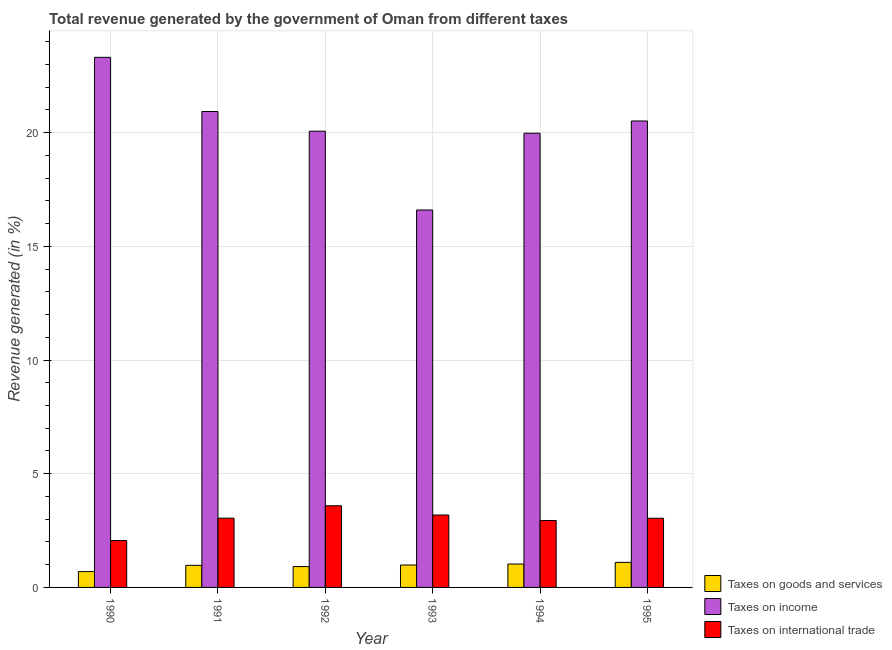Are the number of bars per tick equal to the number of legend labels?
Ensure brevity in your answer.  Yes. How many bars are there on the 6th tick from the left?
Your response must be concise. 3. What is the percentage of revenue generated by taxes on goods and services in 1995?
Your answer should be very brief. 1.1. Across all years, what is the maximum percentage of revenue generated by tax on international trade?
Your answer should be compact. 3.59. Across all years, what is the minimum percentage of revenue generated by tax on international trade?
Your answer should be compact. 2.06. What is the total percentage of revenue generated by tax on international trade in the graph?
Your answer should be very brief. 17.87. What is the difference between the percentage of revenue generated by tax on international trade in 1993 and that in 1995?
Provide a succinct answer. 0.14. What is the difference between the percentage of revenue generated by tax on international trade in 1995 and the percentage of revenue generated by taxes on goods and services in 1990?
Provide a succinct answer. 0.98. What is the average percentage of revenue generated by taxes on income per year?
Provide a short and direct response. 20.23. In the year 1990, what is the difference between the percentage of revenue generated by tax on international trade and percentage of revenue generated by taxes on goods and services?
Give a very brief answer. 0. What is the ratio of the percentage of revenue generated by taxes on goods and services in 1991 to that in 1995?
Your response must be concise. 0.88. Is the percentage of revenue generated by taxes on income in 1990 less than that in 1995?
Offer a terse response. No. Is the difference between the percentage of revenue generated by taxes on income in 1991 and 1993 greater than the difference between the percentage of revenue generated by taxes on goods and services in 1991 and 1993?
Give a very brief answer. No. What is the difference between the highest and the second highest percentage of revenue generated by tax on international trade?
Ensure brevity in your answer.  0.41. What is the difference between the highest and the lowest percentage of revenue generated by taxes on goods and services?
Your answer should be very brief. 0.41. In how many years, is the percentage of revenue generated by taxes on income greater than the average percentage of revenue generated by taxes on income taken over all years?
Offer a terse response. 3. Is the sum of the percentage of revenue generated by taxes on goods and services in 1990 and 1991 greater than the maximum percentage of revenue generated by tax on international trade across all years?
Your answer should be very brief. Yes. What does the 1st bar from the left in 1991 represents?
Give a very brief answer. Taxes on goods and services. What does the 1st bar from the right in 1995 represents?
Provide a short and direct response. Taxes on international trade. How many years are there in the graph?
Give a very brief answer. 6. What is the difference between two consecutive major ticks on the Y-axis?
Give a very brief answer. 5. Does the graph contain grids?
Make the answer very short. Yes. How are the legend labels stacked?
Offer a very short reply. Vertical. What is the title of the graph?
Offer a terse response. Total revenue generated by the government of Oman from different taxes. Does "Central government" appear as one of the legend labels in the graph?
Provide a succinct answer. No. What is the label or title of the X-axis?
Your answer should be very brief. Year. What is the label or title of the Y-axis?
Ensure brevity in your answer.  Revenue generated (in %). What is the Revenue generated (in %) of Taxes on goods and services in 1990?
Your response must be concise. 0.7. What is the Revenue generated (in %) of Taxes on income in 1990?
Provide a succinct answer. 23.31. What is the Revenue generated (in %) in Taxes on international trade in 1990?
Your response must be concise. 2.06. What is the Revenue generated (in %) of Taxes on goods and services in 1991?
Give a very brief answer. 0.97. What is the Revenue generated (in %) in Taxes on income in 1991?
Your response must be concise. 20.93. What is the Revenue generated (in %) in Taxes on international trade in 1991?
Provide a short and direct response. 3.05. What is the Revenue generated (in %) of Taxes on goods and services in 1992?
Offer a very short reply. 0.92. What is the Revenue generated (in %) of Taxes on income in 1992?
Your response must be concise. 20.06. What is the Revenue generated (in %) of Taxes on international trade in 1992?
Ensure brevity in your answer.  3.59. What is the Revenue generated (in %) of Taxes on goods and services in 1993?
Provide a succinct answer. 0.99. What is the Revenue generated (in %) of Taxes on income in 1993?
Provide a succinct answer. 16.6. What is the Revenue generated (in %) in Taxes on international trade in 1993?
Give a very brief answer. 3.18. What is the Revenue generated (in %) of Taxes on goods and services in 1994?
Your response must be concise. 1.03. What is the Revenue generated (in %) of Taxes on income in 1994?
Provide a short and direct response. 19.97. What is the Revenue generated (in %) in Taxes on international trade in 1994?
Provide a succinct answer. 2.94. What is the Revenue generated (in %) in Taxes on goods and services in 1995?
Offer a terse response. 1.1. What is the Revenue generated (in %) in Taxes on income in 1995?
Your response must be concise. 20.51. What is the Revenue generated (in %) in Taxes on international trade in 1995?
Provide a succinct answer. 3.04. Across all years, what is the maximum Revenue generated (in %) in Taxes on goods and services?
Your answer should be very brief. 1.1. Across all years, what is the maximum Revenue generated (in %) in Taxes on income?
Offer a terse response. 23.31. Across all years, what is the maximum Revenue generated (in %) in Taxes on international trade?
Give a very brief answer. 3.59. Across all years, what is the minimum Revenue generated (in %) in Taxes on goods and services?
Make the answer very short. 0.7. Across all years, what is the minimum Revenue generated (in %) in Taxes on income?
Your answer should be compact. 16.6. Across all years, what is the minimum Revenue generated (in %) of Taxes on international trade?
Your answer should be compact. 2.06. What is the total Revenue generated (in %) of Taxes on goods and services in the graph?
Your answer should be compact. 5.7. What is the total Revenue generated (in %) in Taxes on income in the graph?
Keep it short and to the point. 121.38. What is the total Revenue generated (in %) in Taxes on international trade in the graph?
Ensure brevity in your answer.  17.87. What is the difference between the Revenue generated (in %) of Taxes on goods and services in 1990 and that in 1991?
Provide a short and direct response. -0.27. What is the difference between the Revenue generated (in %) of Taxes on income in 1990 and that in 1991?
Your answer should be very brief. 2.38. What is the difference between the Revenue generated (in %) in Taxes on international trade in 1990 and that in 1991?
Provide a short and direct response. -0.98. What is the difference between the Revenue generated (in %) in Taxes on goods and services in 1990 and that in 1992?
Provide a succinct answer. -0.22. What is the difference between the Revenue generated (in %) in Taxes on income in 1990 and that in 1992?
Provide a succinct answer. 3.25. What is the difference between the Revenue generated (in %) of Taxes on international trade in 1990 and that in 1992?
Provide a succinct answer. -1.53. What is the difference between the Revenue generated (in %) in Taxes on goods and services in 1990 and that in 1993?
Give a very brief answer. -0.29. What is the difference between the Revenue generated (in %) in Taxes on income in 1990 and that in 1993?
Ensure brevity in your answer.  6.71. What is the difference between the Revenue generated (in %) in Taxes on international trade in 1990 and that in 1993?
Give a very brief answer. -1.12. What is the difference between the Revenue generated (in %) of Taxes on goods and services in 1990 and that in 1994?
Ensure brevity in your answer.  -0.33. What is the difference between the Revenue generated (in %) in Taxes on income in 1990 and that in 1994?
Provide a succinct answer. 3.34. What is the difference between the Revenue generated (in %) in Taxes on international trade in 1990 and that in 1994?
Your response must be concise. -0.88. What is the difference between the Revenue generated (in %) of Taxes on goods and services in 1990 and that in 1995?
Your response must be concise. -0.41. What is the difference between the Revenue generated (in %) in Taxes on income in 1990 and that in 1995?
Offer a very short reply. 2.8. What is the difference between the Revenue generated (in %) of Taxes on international trade in 1990 and that in 1995?
Your answer should be compact. -0.98. What is the difference between the Revenue generated (in %) in Taxes on goods and services in 1991 and that in 1992?
Your answer should be compact. 0.05. What is the difference between the Revenue generated (in %) in Taxes on income in 1991 and that in 1992?
Ensure brevity in your answer.  0.87. What is the difference between the Revenue generated (in %) of Taxes on international trade in 1991 and that in 1992?
Offer a very short reply. -0.54. What is the difference between the Revenue generated (in %) in Taxes on goods and services in 1991 and that in 1993?
Make the answer very short. -0.01. What is the difference between the Revenue generated (in %) in Taxes on income in 1991 and that in 1993?
Your answer should be very brief. 4.33. What is the difference between the Revenue generated (in %) of Taxes on international trade in 1991 and that in 1993?
Ensure brevity in your answer.  -0.14. What is the difference between the Revenue generated (in %) in Taxes on goods and services in 1991 and that in 1994?
Your response must be concise. -0.06. What is the difference between the Revenue generated (in %) in Taxes on income in 1991 and that in 1994?
Give a very brief answer. 0.96. What is the difference between the Revenue generated (in %) in Taxes on international trade in 1991 and that in 1994?
Your answer should be compact. 0.1. What is the difference between the Revenue generated (in %) of Taxes on goods and services in 1991 and that in 1995?
Your answer should be compact. -0.13. What is the difference between the Revenue generated (in %) of Taxes on income in 1991 and that in 1995?
Keep it short and to the point. 0.42. What is the difference between the Revenue generated (in %) of Taxes on international trade in 1991 and that in 1995?
Keep it short and to the point. 0. What is the difference between the Revenue generated (in %) in Taxes on goods and services in 1992 and that in 1993?
Your answer should be very brief. -0.07. What is the difference between the Revenue generated (in %) of Taxes on income in 1992 and that in 1993?
Your answer should be very brief. 3.47. What is the difference between the Revenue generated (in %) in Taxes on international trade in 1992 and that in 1993?
Ensure brevity in your answer.  0.41. What is the difference between the Revenue generated (in %) in Taxes on goods and services in 1992 and that in 1994?
Your answer should be very brief. -0.11. What is the difference between the Revenue generated (in %) of Taxes on income in 1992 and that in 1994?
Give a very brief answer. 0.09. What is the difference between the Revenue generated (in %) in Taxes on international trade in 1992 and that in 1994?
Provide a short and direct response. 0.65. What is the difference between the Revenue generated (in %) of Taxes on goods and services in 1992 and that in 1995?
Offer a very short reply. -0.18. What is the difference between the Revenue generated (in %) in Taxes on income in 1992 and that in 1995?
Your answer should be very brief. -0.45. What is the difference between the Revenue generated (in %) in Taxes on international trade in 1992 and that in 1995?
Your answer should be compact. 0.55. What is the difference between the Revenue generated (in %) in Taxes on goods and services in 1993 and that in 1994?
Provide a short and direct response. -0.04. What is the difference between the Revenue generated (in %) in Taxes on income in 1993 and that in 1994?
Your answer should be very brief. -3.38. What is the difference between the Revenue generated (in %) in Taxes on international trade in 1993 and that in 1994?
Make the answer very short. 0.24. What is the difference between the Revenue generated (in %) in Taxes on goods and services in 1993 and that in 1995?
Your answer should be very brief. -0.12. What is the difference between the Revenue generated (in %) in Taxes on income in 1993 and that in 1995?
Make the answer very short. -3.91. What is the difference between the Revenue generated (in %) of Taxes on international trade in 1993 and that in 1995?
Provide a succinct answer. 0.14. What is the difference between the Revenue generated (in %) of Taxes on goods and services in 1994 and that in 1995?
Your answer should be very brief. -0.07. What is the difference between the Revenue generated (in %) in Taxes on income in 1994 and that in 1995?
Provide a short and direct response. -0.54. What is the difference between the Revenue generated (in %) in Taxes on international trade in 1994 and that in 1995?
Your answer should be compact. -0.1. What is the difference between the Revenue generated (in %) of Taxes on goods and services in 1990 and the Revenue generated (in %) of Taxes on income in 1991?
Ensure brevity in your answer.  -20.23. What is the difference between the Revenue generated (in %) of Taxes on goods and services in 1990 and the Revenue generated (in %) of Taxes on international trade in 1991?
Your response must be concise. -2.35. What is the difference between the Revenue generated (in %) of Taxes on income in 1990 and the Revenue generated (in %) of Taxes on international trade in 1991?
Ensure brevity in your answer.  20.26. What is the difference between the Revenue generated (in %) in Taxes on goods and services in 1990 and the Revenue generated (in %) in Taxes on income in 1992?
Your answer should be very brief. -19.37. What is the difference between the Revenue generated (in %) in Taxes on goods and services in 1990 and the Revenue generated (in %) in Taxes on international trade in 1992?
Make the answer very short. -2.89. What is the difference between the Revenue generated (in %) in Taxes on income in 1990 and the Revenue generated (in %) in Taxes on international trade in 1992?
Your response must be concise. 19.72. What is the difference between the Revenue generated (in %) of Taxes on goods and services in 1990 and the Revenue generated (in %) of Taxes on income in 1993?
Ensure brevity in your answer.  -15.9. What is the difference between the Revenue generated (in %) of Taxes on goods and services in 1990 and the Revenue generated (in %) of Taxes on international trade in 1993?
Offer a terse response. -2.49. What is the difference between the Revenue generated (in %) of Taxes on income in 1990 and the Revenue generated (in %) of Taxes on international trade in 1993?
Give a very brief answer. 20.13. What is the difference between the Revenue generated (in %) in Taxes on goods and services in 1990 and the Revenue generated (in %) in Taxes on income in 1994?
Offer a terse response. -19.28. What is the difference between the Revenue generated (in %) of Taxes on goods and services in 1990 and the Revenue generated (in %) of Taxes on international trade in 1994?
Give a very brief answer. -2.25. What is the difference between the Revenue generated (in %) in Taxes on income in 1990 and the Revenue generated (in %) in Taxes on international trade in 1994?
Your answer should be very brief. 20.37. What is the difference between the Revenue generated (in %) of Taxes on goods and services in 1990 and the Revenue generated (in %) of Taxes on income in 1995?
Provide a succinct answer. -19.82. What is the difference between the Revenue generated (in %) of Taxes on goods and services in 1990 and the Revenue generated (in %) of Taxes on international trade in 1995?
Your answer should be compact. -2.35. What is the difference between the Revenue generated (in %) in Taxes on income in 1990 and the Revenue generated (in %) in Taxes on international trade in 1995?
Provide a succinct answer. 20.27. What is the difference between the Revenue generated (in %) of Taxes on goods and services in 1991 and the Revenue generated (in %) of Taxes on income in 1992?
Provide a succinct answer. -19.09. What is the difference between the Revenue generated (in %) in Taxes on goods and services in 1991 and the Revenue generated (in %) in Taxes on international trade in 1992?
Provide a succinct answer. -2.62. What is the difference between the Revenue generated (in %) of Taxes on income in 1991 and the Revenue generated (in %) of Taxes on international trade in 1992?
Your response must be concise. 17.34. What is the difference between the Revenue generated (in %) in Taxes on goods and services in 1991 and the Revenue generated (in %) in Taxes on income in 1993?
Provide a succinct answer. -15.63. What is the difference between the Revenue generated (in %) of Taxes on goods and services in 1991 and the Revenue generated (in %) of Taxes on international trade in 1993?
Offer a terse response. -2.21. What is the difference between the Revenue generated (in %) in Taxes on income in 1991 and the Revenue generated (in %) in Taxes on international trade in 1993?
Your response must be concise. 17.75. What is the difference between the Revenue generated (in %) in Taxes on goods and services in 1991 and the Revenue generated (in %) in Taxes on income in 1994?
Provide a short and direct response. -19. What is the difference between the Revenue generated (in %) in Taxes on goods and services in 1991 and the Revenue generated (in %) in Taxes on international trade in 1994?
Provide a short and direct response. -1.97. What is the difference between the Revenue generated (in %) of Taxes on income in 1991 and the Revenue generated (in %) of Taxes on international trade in 1994?
Your response must be concise. 17.99. What is the difference between the Revenue generated (in %) of Taxes on goods and services in 1991 and the Revenue generated (in %) of Taxes on income in 1995?
Provide a short and direct response. -19.54. What is the difference between the Revenue generated (in %) in Taxes on goods and services in 1991 and the Revenue generated (in %) in Taxes on international trade in 1995?
Offer a very short reply. -2.07. What is the difference between the Revenue generated (in %) in Taxes on income in 1991 and the Revenue generated (in %) in Taxes on international trade in 1995?
Provide a succinct answer. 17.89. What is the difference between the Revenue generated (in %) in Taxes on goods and services in 1992 and the Revenue generated (in %) in Taxes on income in 1993?
Your response must be concise. -15.68. What is the difference between the Revenue generated (in %) in Taxes on goods and services in 1992 and the Revenue generated (in %) in Taxes on international trade in 1993?
Provide a succinct answer. -2.27. What is the difference between the Revenue generated (in %) in Taxes on income in 1992 and the Revenue generated (in %) in Taxes on international trade in 1993?
Give a very brief answer. 16.88. What is the difference between the Revenue generated (in %) of Taxes on goods and services in 1992 and the Revenue generated (in %) of Taxes on income in 1994?
Your response must be concise. -19.06. What is the difference between the Revenue generated (in %) of Taxes on goods and services in 1992 and the Revenue generated (in %) of Taxes on international trade in 1994?
Provide a succinct answer. -2.03. What is the difference between the Revenue generated (in %) of Taxes on income in 1992 and the Revenue generated (in %) of Taxes on international trade in 1994?
Your response must be concise. 17.12. What is the difference between the Revenue generated (in %) of Taxes on goods and services in 1992 and the Revenue generated (in %) of Taxes on income in 1995?
Offer a terse response. -19.6. What is the difference between the Revenue generated (in %) in Taxes on goods and services in 1992 and the Revenue generated (in %) in Taxes on international trade in 1995?
Your answer should be very brief. -2.13. What is the difference between the Revenue generated (in %) of Taxes on income in 1992 and the Revenue generated (in %) of Taxes on international trade in 1995?
Provide a short and direct response. 17.02. What is the difference between the Revenue generated (in %) in Taxes on goods and services in 1993 and the Revenue generated (in %) in Taxes on income in 1994?
Provide a short and direct response. -18.99. What is the difference between the Revenue generated (in %) of Taxes on goods and services in 1993 and the Revenue generated (in %) of Taxes on international trade in 1994?
Your answer should be very brief. -1.96. What is the difference between the Revenue generated (in %) in Taxes on income in 1993 and the Revenue generated (in %) in Taxes on international trade in 1994?
Offer a terse response. 13.65. What is the difference between the Revenue generated (in %) of Taxes on goods and services in 1993 and the Revenue generated (in %) of Taxes on income in 1995?
Provide a succinct answer. -19.53. What is the difference between the Revenue generated (in %) of Taxes on goods and services in 1993 and the Revenue generated (in %) of Taxes on international trade in 1995?
Your answer should be compact. -2.06. What is the difference between the Revenue generated (in %) of Taxes on income in 1993 and the Revenue generated (in %) of Taxes on international trade in 1995?
Your answer should be very brief. 13.56. What is the difference between the Revenue generated (in %) of Taxes on goods and services in 1994 and the Revenue generated (in %) of Taxes on income in 1995?
Your response must be concise. -19.48. What is the difference between the Revenue generated (in %) of Taxes on goods and services in 1994 and the Revenue generated (in %) of Taxes on international trade in 1995?
Ensure brevity in your answer.  -2.01. What is the difference between the Revenue generated (in %) of Taxes on income in 1994 and the Revenue generated (in %) of Taxes on international trade in 1995?
Ensure brevity in your answer.  16.93. What is the average Revenue generated (in %) in Taxes on goods and services per year?
Make the answer very short. 0.95. What is the average Revenue generated (in %) in Taxes on income per year?
Make the answer very short. 20.23. What is the average Revenue generated (in %) of Taxes on international trade per year?
Your answer should be very brief. 2.98. In the year 1990, what is the difference between the Revenue generated (in %) of Taxes on goods and services and Revenue generated (in %) of Taxes on income?
Ensure brevity in your answer.  -22.61. In the year 1990, what is the difference between the Revenue generated (in %) in Taxes on goods and services and Revenue generated (in %) in Taxes on international trade?
Provide a short and direct response. -1.37. In the year 1990, what is the difference between the Revenue generated (in %) of Taxes on income and Revenue generated (in %) of Taxes on international trade?
Ensure brevity in your answer.  21.25. In the year 1991, what is the difference between the Revenue generated (in %) in Taxes on goods and services and Revenue generated (in %) in Taxes on income?
Your answer should be compact. -19.96. In the year 1991, what is the difference between the Revenue generated (in %) in Taxes on goods and services and Revenue generated (in %) in Taxes on international trade?
Your response must be concise. -2.07. In the year 1991, what is the difference between the Revenue generated (in %) in Taxes on income and Revenue generated (in %) in Taxes on international trade?
Give a very brief answer. 17.88. In the year 1992, what is the difference between the Revenue generated (in %) of Taxes on goods and services and Revenue generated (in %) of Taxes on income?
Keep it short and to the point. -19.15. In the year 1992, what is the difference between the Revenue generated (in %) in Taxes on goods and services and Revenue generated (in %) in Taxes on international trade?
Make the answer very short. -2.67. In the year 1992, what is the difference between the Revenue generated (in %) in Taxes on income and Revenue generated (in %) in Taxes on international trade?
Offer a terse response. 16.47. In the year 1993, what is the difference between the Revenue generated (in %) of Taxes on goods and services and Revenue generated (in %) of Taxes on income?
Offer a terse response. -15.61. In the year 1993, what is the difference between the Revenue generated (in %) in Taxes on goods and services and Revenue generated (in %) in Taxes on international trade?
Your answer should be very brief. -2.2. In the year 1993, what is the difference between the Revenue generated (in %) in Taxes on income and Revenue generated (in %) in Taxes on international trade?
Ensure brevity in your answer.  13.41. In the year 1994, what is the difference between the Revenue generated (in %) in Taxes on goods and services and Revenue generated (in %) in Taxes on income?
Give a very brief answer. -18.94. In the year 1994, what is the difference between the Revenue generated (in %) in Taxes on goods and services and Revenue generated (in %) in Taxes on international trade?
Make the answer very short. -1.92. In the year 1994, what is the difference between the Revenue generated (in %) in Taxes on income and Revenue generated (in %) in Taxes on international trade?
Make the answer very short. 17.03. In the year 1995, what is the difference between the Revenue generated (in %) of Taxes on goods and services and Revenue generated (in %) of Taxes on income?
Provide a succinct answer. -19.41. In the year 1995, what is the difference between the Revenue generated (in %) in Taxes on goods and services and Revenue generated (in %) in Taxes on international trade?
Provide a succinct answer. -1.94. In the year 1995, what is the difference between the Revenue generated (in %) in Taxes on income and Revenue generated (in %) in Taxes on international trade?
Provide a succinct answer. 17.47. What is the ratio of the Revenue generated (in %) of Taxes on goods and services in 1990 to that in 1991?
Make the answer very short. 0.72. What is the ratio of the Revenue generated (in %) in Taxes on income in 1990 to that in 1991?
Your response must be concise. 1.11. What is the ratio of the Revenue generated (in %) of Taxes on international trade in 1990 to that in 1991?
Offer a very short reply. 0.68. What is the ratio of the Revenue generated (in %) of Taxes on goods and services in 1990 to that in 1992?
Ensure brevity in your answer.  0.76. What is the ratio of the Revenue generated (in %) in Taxes on income in 1990 to that in 1992?
Make the answer very short. 1.16. What is the ratio of the Revenue generated (in %) in Taxes on international trade in 1990 to that in 1992?
Offer a very short reply. 0.57. What is the ratio of the Revenue generated (in %) in Taxes on goods and services in 1990 to that in 1993?
Provide a succinct answer. 0.71. What is the ratio of the Revenue generated (in %) in Taxes on income in 1990 to that in 1993?
Offer a terse response. 1.4. What is the ratio of the Revenue generated (in %) of Taxes on international trade in 1990 to that in 1993?
Your answer should be very brief. 0.65. What is the ratio of the Revenue generated (in %) of Taxes on goods and services in 1990 to that in 1994?
Your response must be concise. 0.68. What is the ratio of the Revenue generated (in %) in Taxes on income in 1990 to that in 1994?
Your answer should be very brief. 1.17. What is the ratio of the Revenue generated (in %) in Taxes on international trade in 1990 to that in 1994?
Offer a very short reply. 0.7. What is the ratio of the Revenue generated (in %) of Taxes on goods and services in 1990 to that in 1995?
Provide a short and direct response. 0.63. What is the ratio of the Revenue generated (in %) of Taxes on income in 1990 to that in 1995?
Your answer should be very brief. 1.14. What is the ratio of the Revenue generated (in %) of Taxes on international trade in 1990 to that in 1995?
Keep it short and to the point. 0.68. What is the ratio of the Revenue generated (in %) of Taxes on goods and services in 1991 to that in 1992?
Your answer should be very brief. 1.06. What is the ratio of the Revenue generated (in %) of Taxes on income in 1991 to that in 1992?
Offer a terse response. 1.04. What is the ratio of the Revenue generated (in %) of Taxes on international trade in 1991 to that in 1992?
Offer a very short reply. 0.85. What is the ratio of the Revenue generated (in %) in Taxes on goods and services in 1991 to that in 1993?
Give a very brief answer. 0.98. What is the ratio of the Revenue generated (in %) of Taxes on income in 1991 to that in 1993?
Provide a succinct answer. 1.26. What is the ratio of the Revenue generated (in %) of Taxes on international trade in 1991 to that in 1993?
Your answer should be very brief. 0.96. What is the ratio of the Revenue generated (in %) in Taxes on goods and services in 1991 to that in 1994?
Provide a short and direct response. 0.94. What is the ratio of the Revenue generated (in %) in Taxes on income in 1991 to that in 1994?
Your answer should be very brief. 1.05. What is the ratio of the Revenue generated (in %) of Taxes on international trade in 1991 to that in 1994?
Your response must be concise. 1.03. What is the ratio of the Revenue generated (in %) in Taxes on goods and services in 1991 to that in 1995?
Keep it short and to the point. 0.88. What is the ratio of the Revenue generated (in %) of Taxes on income in 1991 to that in 1995?
Provide a succinct answer. 1.02. What is the ratio of the Revenue generated (in %) in Taxes on goods and services in 1992 to that in 1993?
Your response must be concise. 0.93. What is the ratio of the Revenue generated (in %) in Taxes on income in 1992 to that in 1993?
Provide a succinct answer. 1.21. What is the ratio of the Revenue generated (in %) in Taxes on international trade in 1992 to that in 1993?
Offer a very short reply. 1.13. What is the ratio of the Revenue generated (in %) in Taxes on goods and services in 1992 to that in 1994?
Keep it short and to the point. 0.89. What is the ratio of the Revenue generated (in %) of Taxes on income in 1992 to that in 1994?
Your answer should be very brief. 1. What is the ratio of the Revenue generated (in %) in Taxes on international trade in 1992 to that in 1994?
Keep it short and to the point. 1.22. What is the ratio of the Revenue generated (in %) of Taxes on goods and services in 1992 to that in 1995?
Your response must be concise. 0.83. What is the ratio of the Revenue generated (in %) in Taxes on income in 1992 to that in 1995?
Keep it short and to the point. 0.98. What is the ratio of the Revenue generated (in %) in Taxes on international trade in 1992 to that in 1995?
Keep it short and to the point. 1.18. What is the ratio of the Revenue generated (in %) in Taxes on goods and services in 1993 to that in 1994?
Ensure brevity in your answer.  0.96. What is the ratio of the Revenue generated (in %) of Taxes on income in 1993 to that in 1994?
Give a very brief answer. 0.83. What is the ratio of the Revenue generated (in %) in Taxes on international trade in 1993 to that in 1994?
Your response must be concise. 1.08. What is the ratio of the Revenue generated (in %) of Taxes on goods and services in 1993 to that in 1995?
Your response must be concise. 0.9. What is the ratio of the Revenue generated (in %) in Taxes on income in 1993 to that in 1995?
Your response must be concise. 0.81. What is the ratio of the Revenue generated (in %) of Taxes on international trade in 1993 to that in 1995?
Offer a terse response. 1.05. What is the ratio of the Revenue generated (in %) in Taxes on goods and services in 1994 to that in 1995?
Your response must be concise. 0.93. What is the ratio of the Revenue generated (in %) in Taxes on income in 1994 to that in 1995?
Make the answer very short. 0.97. What is the ratio of the Revenue generated (in %) in Taxes on international trade in 1994 to that in 1995?
Your response must be concise. 0.97. What is the difference between the highest and the second highest Revenue generated (in %) in Taxes on goods and services?
Provide a succinct answer. 0.07. What is the difference between the highest and the second highest Revenue generated (in %) in Taxes on income?
Your answer should be very brief. 2.38. What is the difference between the highest and the second highest Revenue generated (in %) of Taxes on international trade?
Provide a succinct answer. 0.41. What is the difference between the highest and the lowest Revenue generated (in %) of Taxes on goods and services?
Offer a terse response. 0.41. What is the difference between the highest and the lowest Revenue generated (in %) in Taxes on income?
Offer a terse response. 6.71. What is the difference between the highest and the lowest Revenue generated (in %) of Taxes on international trade?
Give a very brief answer. 1.53. 